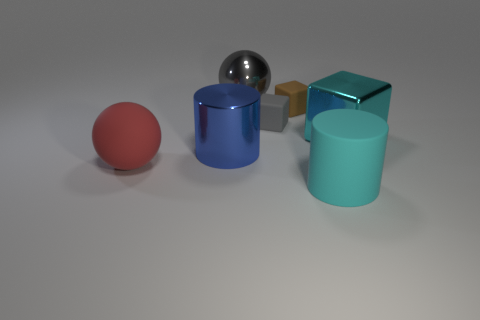What materials do the objects appear to be made of? The objects seem to have different textures: the red and cyan objects appear to be made of a matte rubber material, the blue cylinder has a metallic finish suggestive of painted metal, the silver sphere looks like polished steel, and the combination of the brown and gold cubes resembles a metallic surface, possibly with a wooden and gold leaf finish. 